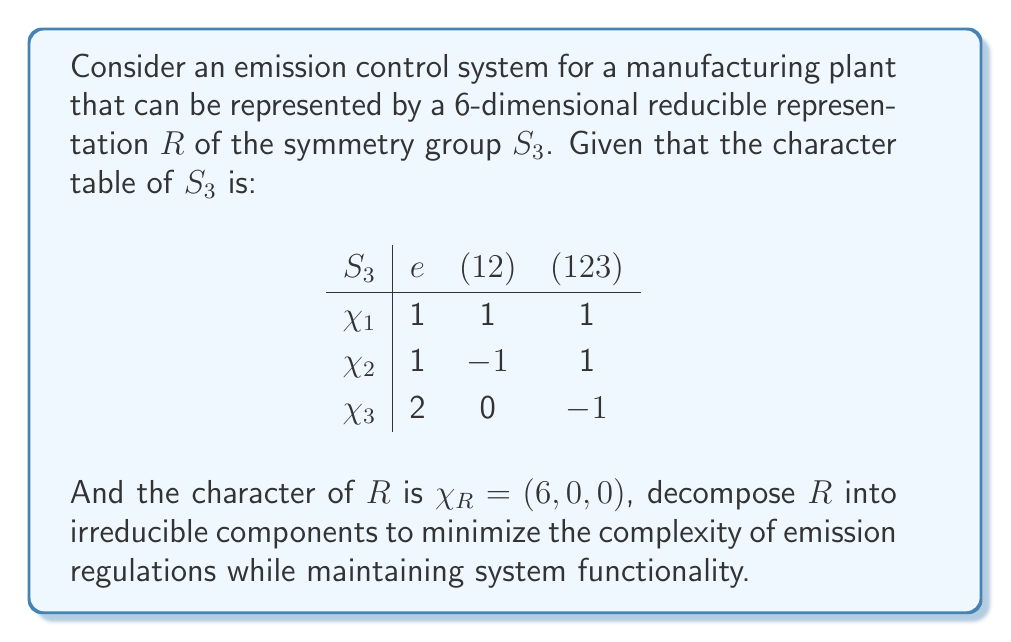Solve this math problem. To decompose the reducible representation $R$ into irreducible components, we need to calculate the multiplicities of each irreducible representation in $R$. We'll use the formula:

$$m_i = \frac{1}{|G|} \sum_{g \in G} \chi_R(g) \chi_i(g)^*$$

Where $|G|$ is the order of the group (6 for $S_3$), $\chi_R$ is the character of our reducible representation, and $\chi_i$ are the characters of the irreducible representations.

For $\chi_1$:
$$m_1 = \frac{1}{6}(6 \cdot 1 + 0 \cdot 1 + 0 \cdot 1) = 1$$

For $\chi_2$:
$$m_2 = \frac{1}{6}(6 \cdot 1 + 0 \cdot (-1) + 0 \cdot 1) = 1$$

For $\chi_3$:
$$m_3 = \frac{1}{6}(6 \cdot 2 + 0 \cdot 0 + 0 \cdot (-1)) = 2$$

Therefore, the decomposition of $R$ is:

$$R = \chi_1 \oplus \chi_2 \oplus 2\chi_3$$

This decomposition shows that the emission control system can be simplified into four components: one corresponding to $\chi_1$, one to $\chi_2$, and two to $\chi_3$. This simplification could potentially reduce the complexity of emission regulations while maintaining the system's functionality.
Answer: $R = \chi_1 \oplus \chi_2 \oplus 2\chi_3$ 